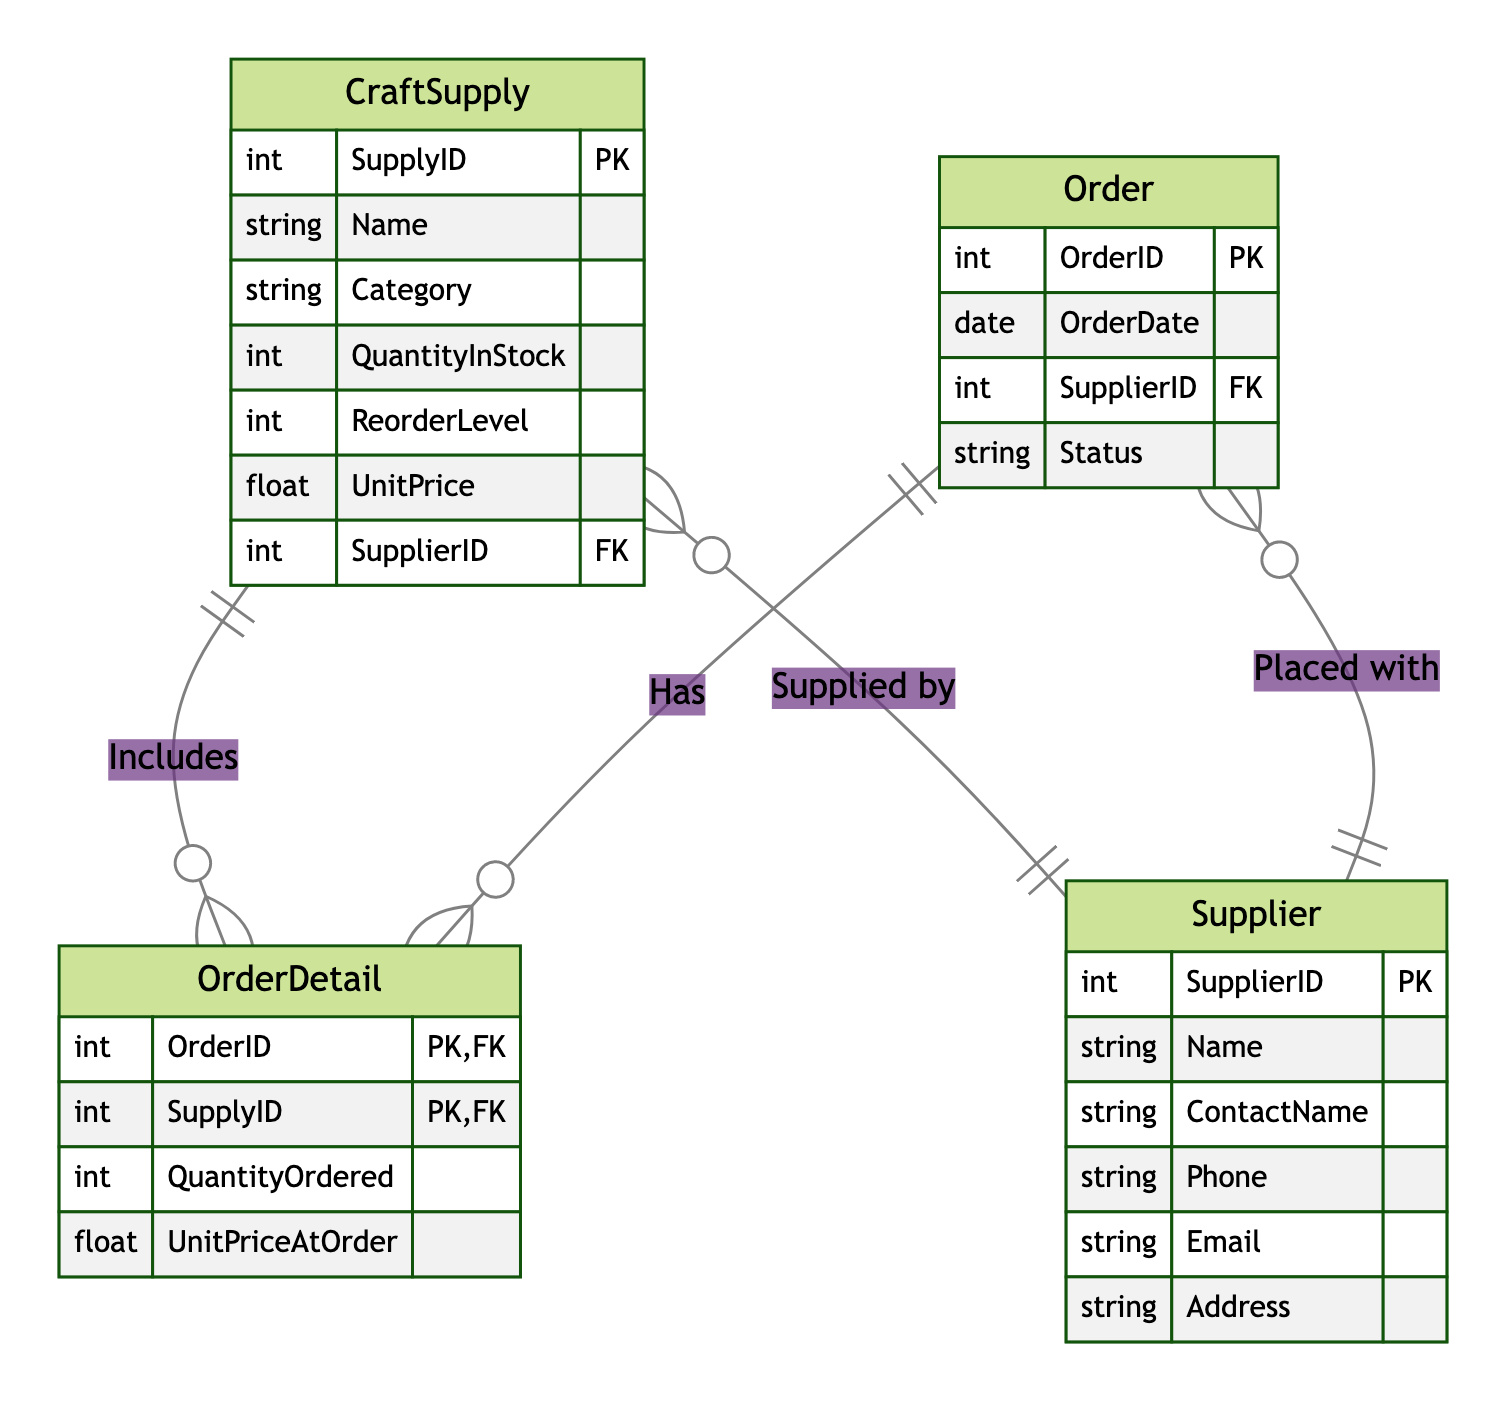What is the primary key of the Supplier entity? The primary key of the Supplier entity is SupplierID, which uniquely identifies each supplier in the database.
Answer: SupplierID How many entities are there in the diagram? The diagram includes four entities: CraftSupply, Supplier, Order, and OrderDetail. Therefore, the total count of entities is four.
Answer: 4 What relationship is represented between Order and OrderDetail? The relationship between Order and OrderDetail is labeled as "Has," indicating that one Order can have multiple OrderDetails associated with it, making it a one-to-many relationship.
Answer: Has What is the foreign key in the CraftSupply entity? In the CraftSupply entity, the foreign key is SupplierID, which links each craft supply item to the supplier that provides it.
Answer: SupplierID Which entity includes the QuantityOrdered attribute? The QuantityOrdered attribute is included in the OrderDetail entity, indicating the amount of each craft supply ordered in a particular order.
Answer: OrderDetail In how many relationships is the Supplier entity involved? The Supplier entity is involved in two relationships: one with CraftSupply (Supplies) and one with Order (Placed with). Therefore, it participates in two relationships in total.
Answer: 2 What type of relationship is represented between OrderDetail and CraftSupply? The relationship between OrderDetail and CraftSupply is a many-to-one relationship, indicating that multiple order details can reference the same craft supply item.
Answer: many-to-one Which attribute in the Order entity indicates the supplier? The SupplierID attribute in the Order entity indicates which supplier the order is placed with, providing a link to the corresponding Supplier entity.
Answer: SupplierID How many primary keys are there in the OrderDetail entity? The OrderDetail entity has two primary keys: OrderID and SupplyID. This composite key ensures that each detail entry is unique based on both the order and the specific supply item.
Answer: 2 